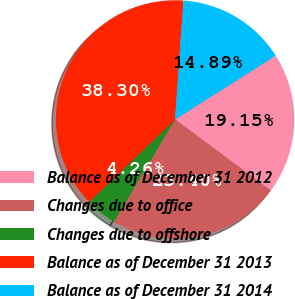Convert chart to OTSL. <chart><loc_0><loc_0><loc_500><loc_500><pie_chart><fcel>Balance as of December 31 2012<fcel>Changes due to office<fcel>Changes due to offshore<fcel>Balance as of December 31 2013<fcel>Balance as of December 31 2014<nl><fcel>19.15%<fcel>23.4%<fcel>4.26%<fcel>38.3%<fcel>14.89%<nl></chart> 